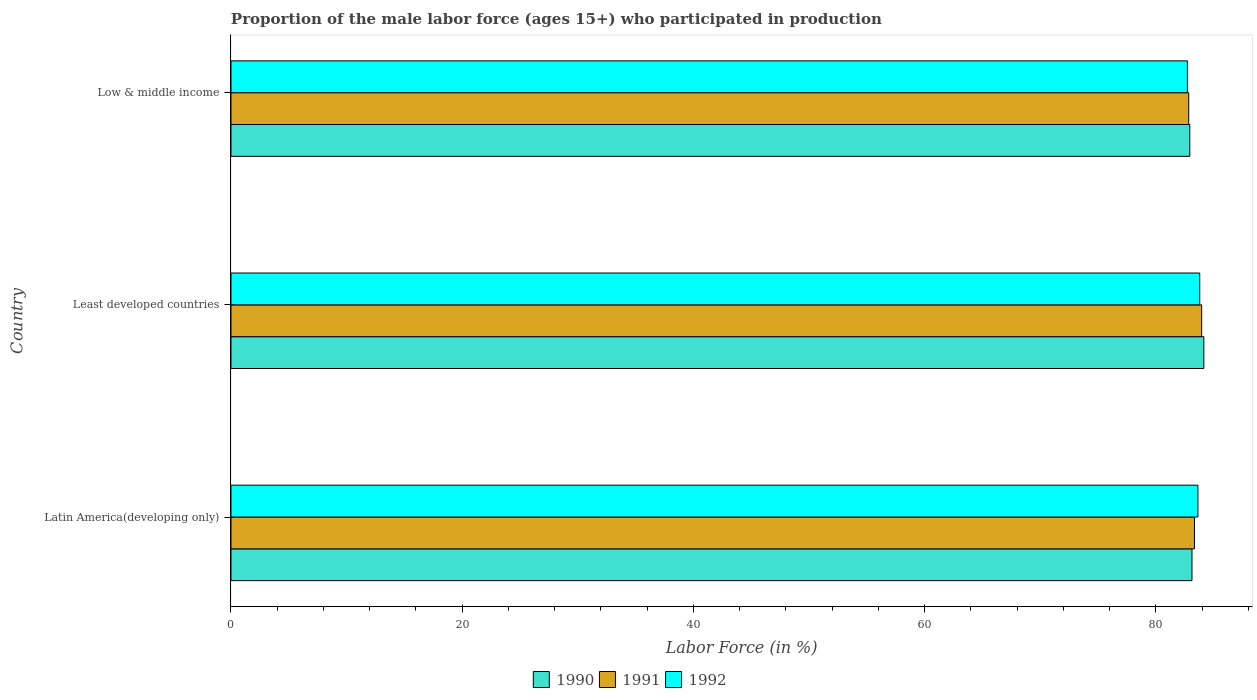How many different coloured bars are there?
Make the answer very short. 3. How many groups of bars are there?
Offer a very short reply. 3. Are the number of bars per tick equal to the number of legend labels?
Your answer should be very brief. Yes. How many bars are there on the 1st tick from the top?
Offer a very short reply. 3. What is the label of the 1st group of bars from the top?
Give a very brief answer. Low & middle income. What is the proportion of the male labor force who participated in production in 1992 in Latin America(developing only)?
Provide a short and direct response. 83.63. Across all countries, what is the maximum proportion of the male labor force who participated in production in 1991?
Give a very brief answer. 83.95. Across all countries, what is the minimum proportion of the male labor force who participated in production in 1992?
Your response must be concise. 82.72. In which country was the proportion of the male labor force who participated in production in 1991 maximum?
Make the answer very short. Least developed countries. What is the total proportion of the male labor force who participated in production in 1990 in the graph?
Offer a very short reply. 250.18. What is the difference between the proportion of the male labor force who participated in production in 1991 in Latin America(developing only) and that in Least developed countries?
Offer a terse response. -0.62. What is the difference between the proportion of the male labor force who participated in production in 1991 in Low & middle income and the proportion of the male labor force who participated in production in 1990 in Least developed countries?
Give a very brief answer. -1.31. What is the average proportion of the male labor force who participated in production in 1991 per country?
Offer a very short reply. 83.37. What is the difference between the proportion of the male labor force who participated in production in 1992 and proportion of the male labor force who participated in production in 1990 in Low & middle income?
Provide a short and direct response. -0.21. What is the ratio of the proportion of the male labor force who participated in production in 1990 in Latin America(developing only) to that in Low & middle income?
Ensure brevity in your answer.  1. Is the proportion of the male labor force who participated in production in 1990 in Latin America(developing only) less than that in Least developed countries?
Make the answer very short. Yes. Is the difference between the proportion of the male labor force who participated in production in 1992 in Latin America(developing only) and Low & middle income greater than the difference between the proportion of the male labor force who participated in production in 1990 in Latin America(developing only) and Low & middle income?
Make the answer very short. Yes. What is the difference between the highest and the second highest proportion of the male labor force who participated in production in 1991?
Your answer should be compact. 0.62. What is the difference between the highest and the lowest proportion of the male labor force who participated in production in 1991?
Offer a terse response. 1.12. In how many countries, is the proportion of the male labor force who participated in production in 1991 greater than the average proportion of the male labor force who participated in production in 1991 taken over all countries?
Ensure brevity in your answer.  1. What does the 1st bar from the top in Latin America(developing only) represents?
Your response must be concise. 1992. What does the 1st bar from the bottom in Low & middle income represents?
Your response must be concise. 1990. How many bars are there?
Provide a short and direct response. 9. Are all the bars in the graph horizontal?
Your response must be concise. Yes. How many countries are there in the graph?
Your response must be concise. 3. Are the values on the major ticks of X-axis written in scientific E-notation?
Give a very brief answer. No. Where does the legend appear in the graph?
Provide a short and direct response. Bottom center. How are the legend labels stacked?
Make the answer very short. Horizontal. What is the title of the graph?
Give a very brief answer. Proportion of the male labor force (ages 15+) who participated in production. Does "1974" appear as one of the legend labels in the graph?
Give a very brief answer. No. What is the Labor Force (in %) of 1990 in Latin America(developing only)?
Offer a terse response. 83.11. What is the Labor Force (in %) of 1991 in Latin America(developing only)?
Your answer should be very brief. 83.33. What is the Labor Force (in %) in 1992 in Latin America(developing only)?
Keep it short and to the point. 83.63. What is the Labor Force (in %) of 1990 in Least developed countries?
Give a very brief answer. 84.14. What is the Labor Force (in %) of 1991 in Least developed countries?
Your answer should be very brief. 83.95. What is the Labor Force (in %) in 1992 in Least developed countries?
Ensure brevity in your answer.  83.78. What is the Labor Force (in %) of 1990 in Low & middle income?
Ensure brevity in your answer.  82.93. What is the Labor Force (in %) in 1991 in Low & middle income?
Keep it short and to the point. 82.83. What is the Labor Force (in %) in 1992 in Low & middle income?
Your answer should be compact. 82.72. Across all countries, what is the maximum Labor Force (in %) in 1990?
Your response must be concise. 84.14. Across all countries, what is the maximum Labor Force (in %) of 1991?
Offer a terse response. 83.95. Across all countries, what is the maximum Labor Force (in %) of 1992?
Your response must be concise. 83.78. Across all countries, what is the minimum Labor Force (in %) of 1990?
Make the answer very short. 82.93. Across all countries, what is the minimum Labor Force (in %) of 1991?
Offer a very short reply. 82.83. Across all countries, what is the minimum Labor Force (in %) of 1992?
Keep it short and to the point. 82.72. What is the total Labor Force (in %) of 1990 in the graph?
Your answer should be very brief. 250.18. What is the total Labor Force (in %) in 1991 in the graph?
Ensure brevity in your answer.  250.11. What is the total Labor Force (in %) in 1992 in the graph?
Keep it short and to the point. 250.13. What is the difference between the Labor Force (in %) in 1990 in Latin America(developing only) and that in Least developed countries?
Make the answer very short. -1.03. What is the difference between the Labor Force (in %) of 1991 in Latin America(developing only) and that in Least developed countries?
Offer a terse response. -0.62. What is the difference between the Labor Force (in %) of 1992 in Latin America(developing only) and that in Least developed countries?
Your answer should be compact. -0.16. What is the difference between the Labor Force (in %) in 1990 in Latin America(developing only) and that in Low & middle income?
Provide a short and direct response. 0.19. What is the difference between the Labor Force (in %) in 1991 in Latin America(developing only) and that in Low & middle income?
Provide a succinct answer. 0.5. What is the difference between the Labor Force (in %) in 1992 in Latin America(developing only) and that in Low & middle income?
Your response must be concise. 0.91. What is the difference between the Labor Force (in %) of 1990 in Least developed countries and that in Low & middle income?
Keep it short and to the point. 1.21. What is the difference between the Labor Force (in %) of 1991 in Least developed countries and that in Low & middle income?
Ensure brevity in your answer.  1.12. What is the difference between the Labor Force (in %) in 1992 in Least developed countries and that in Low & middle income?
Provide a short and direct response. 1.07. What is the difference between the Labor Force (in %) of 1990 in Latin America(developing only) and the Labor Force (in %) of 1991 in Least developed countries?
Provide a succinct answer. -0.84. What is the difference between the Labor Force (in %) of 1990 in Latin America(developing only) and the Labor Force (in %) of 1992 in Least developed countries?
Ensure brevity in your answer.  -0.67. What is the difference between the Labor Force (in %) of 1991 in Latin America(developing only) and the Labor Force (in %) of 1992 in Least developed countries?
Offer a very short reply. -0.46. What is the difference between the Labor Force (in %) in 1990 in Latin America(developing only) and the Labor Force (in %) in 1991 in Low & middle income?
Make the answer very short. 0.28. What is the difference between the Labor Force (in %) in 1990 in Latin America(developing only) and the Labor Force (in %) in 1992 in Low & middle income?
Keep it short and to the point. 0.4. What is the difference between the Labor Force (in %) of 1991 in Latin America(developing only) and the Labor Force (in %) of 1992 in Low & middle income?
Ensure brevity in your answer.  0.61. What is the difference between the Labor Force (in %) in 1990 in Least developed countries and the Labor Force (in %) in 1991 in Low & middle income?
Provide a succinct answer. 1.31. What is the difference between the Labor Force (in %) of 1990 in Least developed countries and the Labor Force (in %) of 1992 in Low & middle income?
Give a very brief answer. 1.42. What is the difference between the Labor Force (in %) of 1991 in Least developed countries and the Labor Force (in %) of 1992 in Low & middle income?
Give a very brief answer. 1.23. What is the average Labor Force (in %) of 1990 per country?
Offer a very short reply. 83.39. What is the average Labor Force (in %) in 1991 per country?
Your answer should be very brief. 83.37. What is the average Labor Force (in %) in 1992 per country?
Offer a terse response. 83.38. What is the difference between the Labor Force (in %) of 1990 and Labor Force (in %) of 1991 in Latin America(developing only)?
Your response must be concise. -0.22. What is the difference between the Labor Force (in %) of 1990 and Labor Force (in %) of 1992 in Latin America(developing only)?
Your answer should be very brief. -0.51. What is the difference between the Labor Force (in %) of 1991 and Labor Force (in %) of 1992 in Latin America(developing only)?
Make the answer very short. -0.3. What is the difference between the Labor Force (in %) in 1990 and Labor Force (in %) in 1991 in Least developed countries?
Your answer should be compact. 0.19. What is the difference between the Labor Force (in %) of 1990 and Labor Force (in %) of 1992 in Least developed countries?
Ensure brevity in your answer.  0.36. What is the difference between the Labor Force (in %) in 1990 and Labor Force (in %) in 1991 in Low & middle income?
Offer a terse response. 0.09. What is the difference between the Labor Force (in %) in 1990 and Labor Force (in %) in 1992 in Low & middle income?
Your response must be concise. 0.21. What is the difference between the Labor Force (in %) in 1991 and Labor Force (in %) in 1992 in Low & middle income?
Your answer should be compact. 0.12. What is the ratio of the Labor Force (in %) in 1991 in Latin America(developing only) to that in Least developed countries?
Make the answer very short. 0.99. What is the ratio of the Labor Force (in %) in 1991 in Latin America(developing only) to that in Low & middle income?
Provide a succinct answer. 1.01. What is the ratio of the Labor Force (in %) of 1992 in Latin America(developing only) to that in Low & middle income?
Your answer should be compact. 1.01. What is the ratio of the Labor Force (in %) in 1990 in Least developed countries to that in Low & middle income?
Your answer should be compact. 1.01. What is the ratio of the Labor Force (in %) of 1991 in Least developed countries to that in Low & middle income?
Offer a very short reply. 1.01. What is the ratio of the Labor Force (in %) in 1992 in Least developed countries to that in Low & middle income?
Ensure brevity in your answer.  1.01. What is the difference between the highest and the second highest Labor Force (in %) in 1990?
Keep it short and to the point. 1.03. What is the difference between the highest and the second highest Labor Force (in %) of 1991?
Your answer should be very brief. 0.62. What is the difference between the highest and the second highest Labor Force (in %) in 1992?
Your answer should be very brief. 0.16. What is the difference between the highest and the lowest Labor Force (in %) of 1990?
Keep it short and to the point. 1.21. What is the difference between the highest and the lowest Labor Force (in %) of 1991?
Offer a very short reply. 1.12. What is the difference between the highest and the lowest Labor Force (in %) in 1992?
Your answer should be very brief. 1.07. 